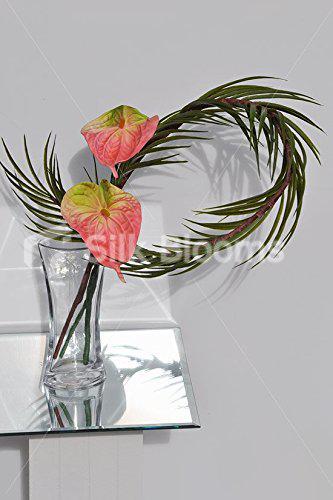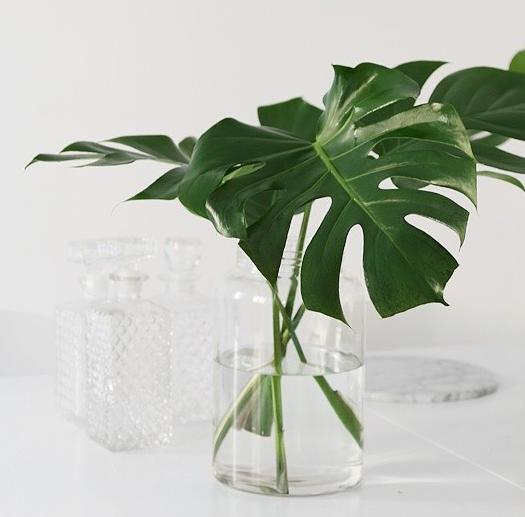The first image is the image on the left, the second image is the image on the right. Analyze the images presented: Is the assertion "In one image, a clear glass vase contains three stems of shiny, wide, dark green leaves that are arranged with each leaning in a different direction." valid? Answer yes or no. Yes. The first image is the image on the left, the second image is the image on the right. Assess this claim about the two images: "The right image includes a vase holding green fronds that don't have spiky grass-like leaves.". Correct or not? Answer yes or no. Yes. 